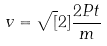Convert formula to latex. <formula><loc_0><loc_0><loc_500><loc_500>v = \sqrt { [ } 2 ] { \frac { 2 P t } { m } }</formula> 